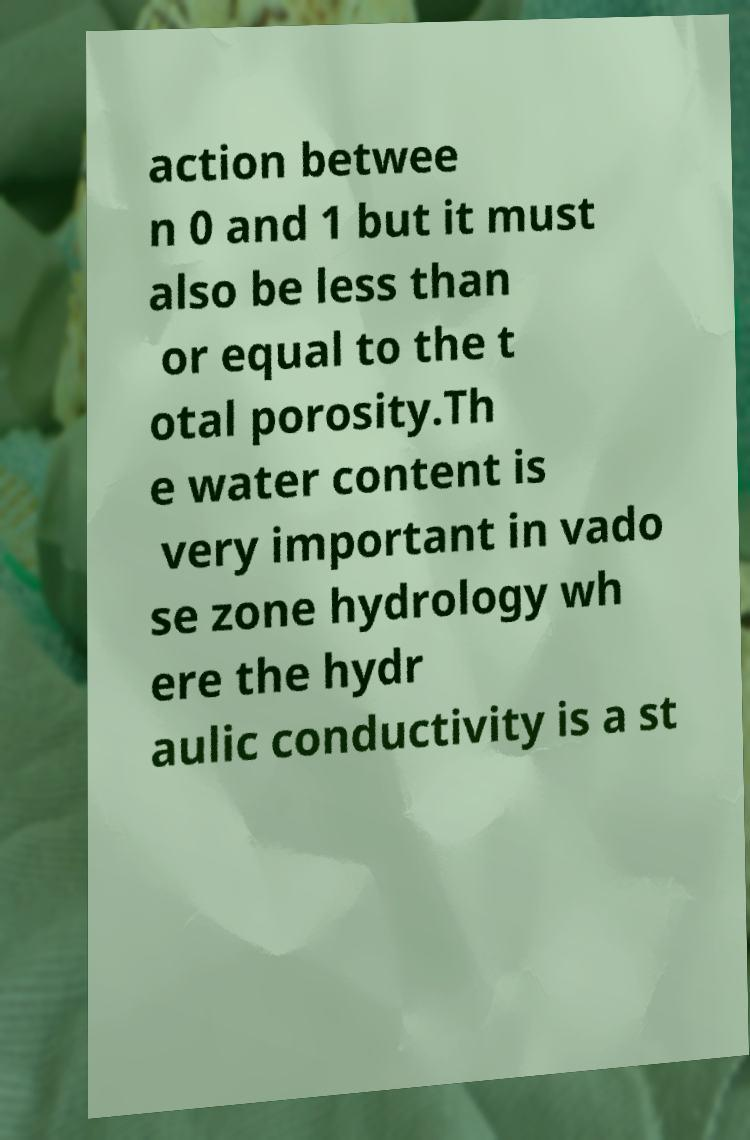What messages or text are displayed in this image? I need them in a readable, typed format. action betwee n 0 and 1 but it must also be less than or equal to the t otal porosity.Th e water content is very important in vado se zone hydrology wh ere the hydr aulic conductivity is a st 